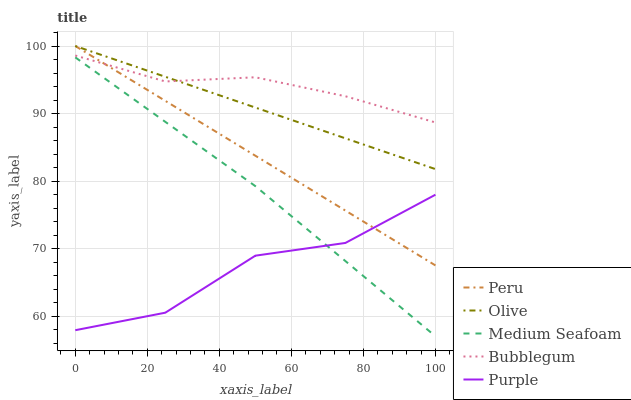Does Purple have the minimum area under the curve?
Answer yes or no. Yes. Does Bubblegum have the maximum area under the curve?
Answer yes or no. Yes. Does Bubblegum have the minimum area under the curve?
Answer yes or no. No. Does Purple have the maximum area under the curve?
Answer yes or no. No. Is Olive the smoothest?
Answer yes or no. Yes. Is Purple the roughest?
Answer yes or no. Yes. Is Bubblegum the smoothest?
Answer yes or no. No. Is Bubblegum the roughest?
Answer yes or no. No. Does Medium Seafoam have the lowest value?
Answer yes or no. Yes. Does Purple have the lowest value?
Answer yes or no. No. Does Peru have the highest value?
Answer yes or no. Yes. Does Bubblegum have the highest value?
Answer yes or no. No. Is Medium Seafoam less than Olive?
Answer yes or no. Yes. Is Bubblegum greater than Purple?
Answer yes or no. Yes. Does Medium Seafoam intersect Purple?
Answer yes or no. Yes. Is Medium Seafoam less than Purple?
Answer yes or no. No. Is Medium Seafoam greater than Purple?
Answer yes or no. No. Does Medium Seafoam intersect Olive?
Answer yes or no. No. 